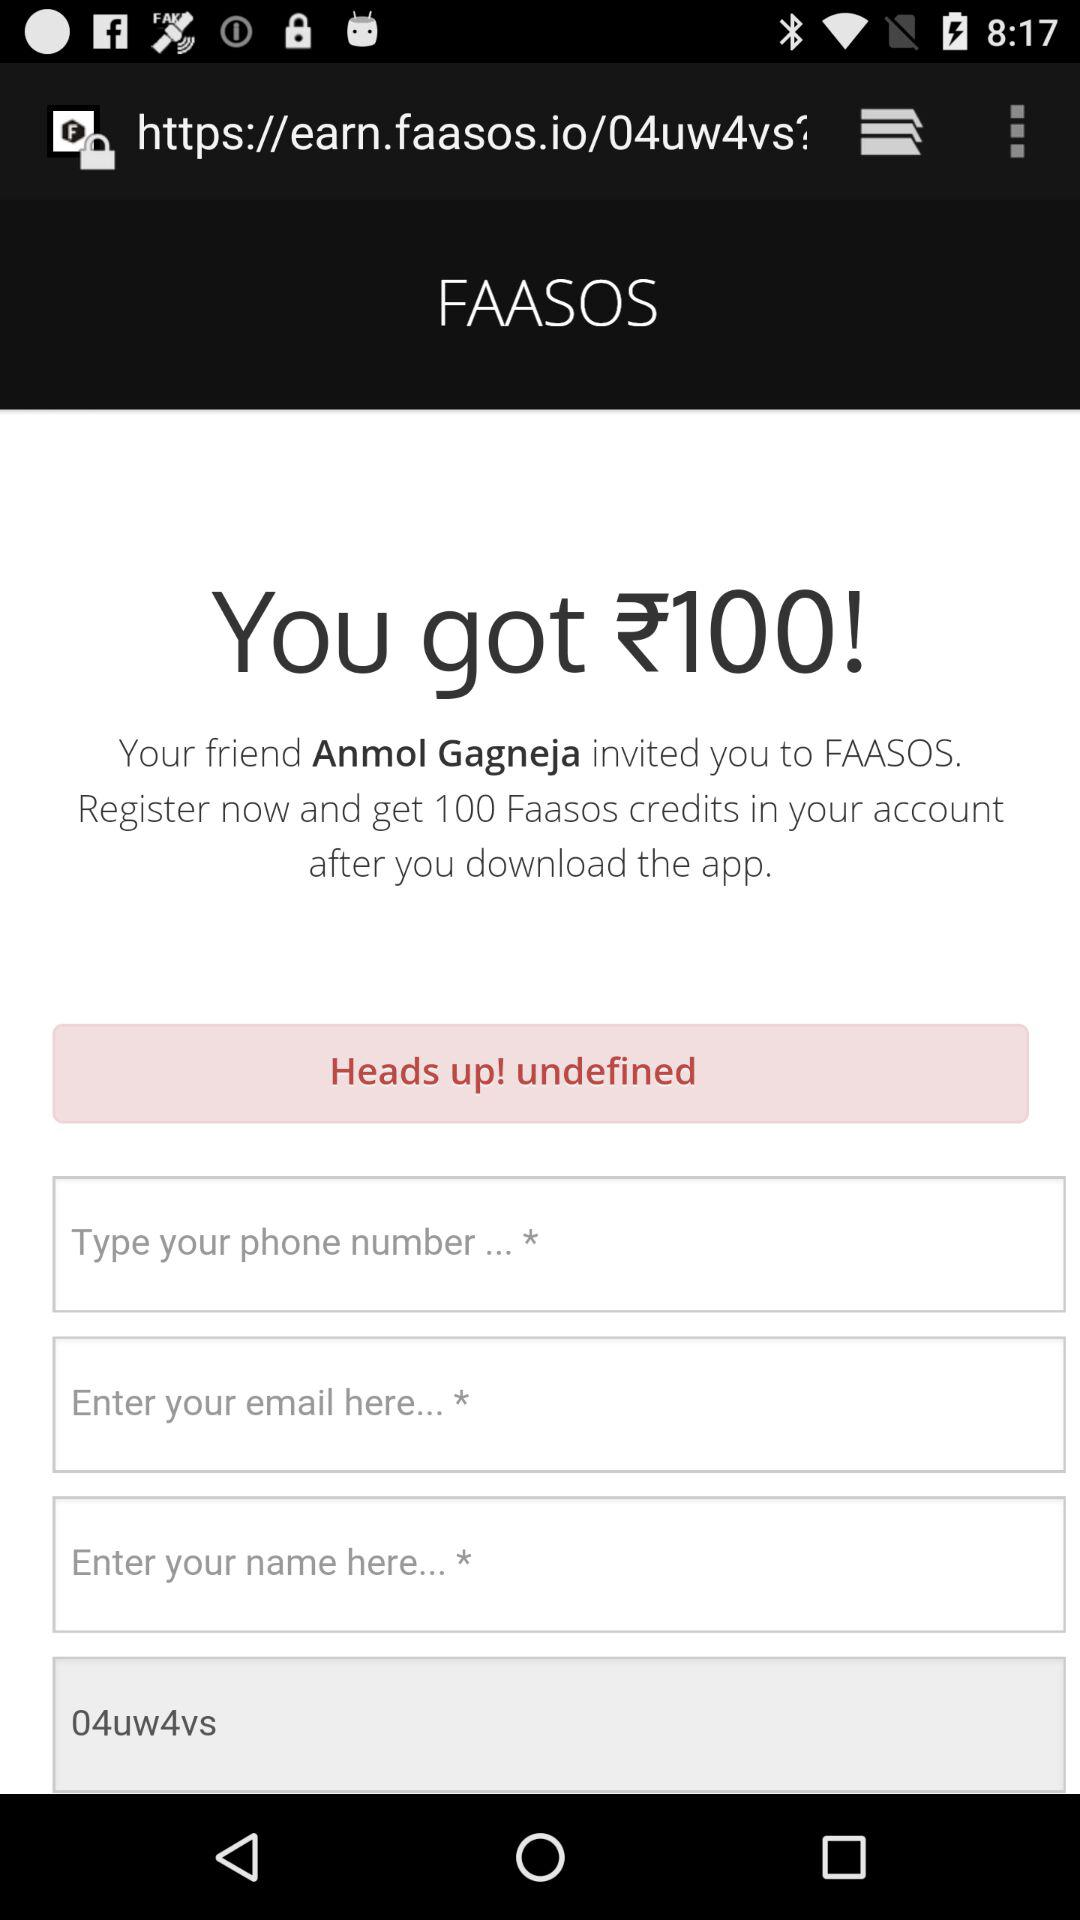How much money did we get? You got 100 rupees. 